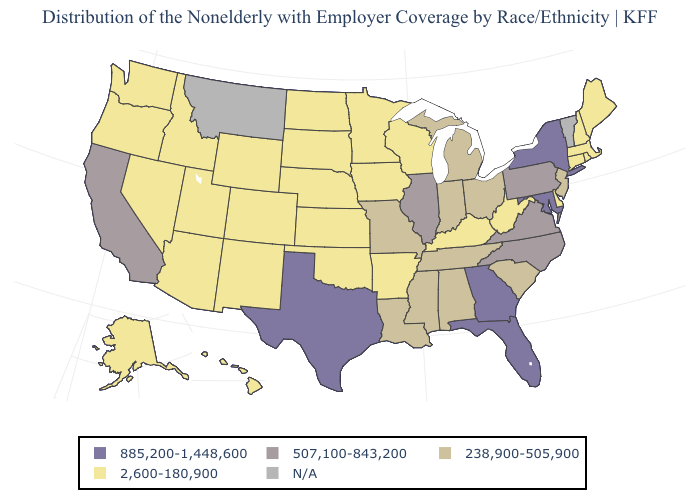Name the states that have a value in the range 2,600-180,900?
Write a very short answer. Alaska, Arizona, Arkansas, Colorado, Connecticut, Delaware, Hawaii, Idaho, Iowa, Kansas, Kentucky, Maine, Massachusetts, Minnesota, Nebraska, Nevada, New Hampshire, New Mexico, North Dakota, Oklahoma, Oregon, Rhode Island, South Dakota, Utah, Washington, West Virginia, Wisconsin, Wyoming. What is the value of Florida?
Quick response, please. 885,200-1,448,600. Among the states that border Virginia , does Maryland have the highest value?
Quick response, please. Yes. Does Pennsylvania have the lowest value in the Northeast?
Short answer required. No. How many symbols are there in the legend?
Write a very short answer. 5. What is the value of Kentucky?
Give a very brief answer. 2,600-180,900. Does Texas have the highest value in the South?
Write a very short answer. Yes. What is the highest value in states that border Idaho?
Short answer required. 2,600-180,900. Name the states that have a value in the range N/A?
Be succinct. Montana, Vermont. Does New York have the highest value in the USA?
Give a very brief answer. Yes. What is the value of Georgia?
Keep it brief. 885,200-1,448,600. What is the highest value in the USA?
Keep it brief. 885,200-1,448,600. What is the value of Arizona?
Short answer required. 2,600-180,900. Does California have the highest value in the West?
Be succinct. Yes. 